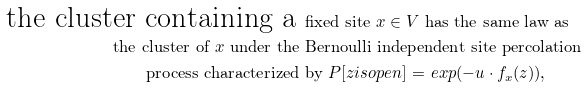<formula> <loc_0><loc_0><loc_500><loc_500>\text {the cluster containing a } & \text {fixed site $x \in V$ has the same law as} \\ \text {the cluster of $x$ under the } & \text {Bernoulli independent site percolation} \\ \text {process characterized } & \text {by $P[z is open ]$ $=$ $exp(-u \cdot f_{x}(z))$,}</formula> 